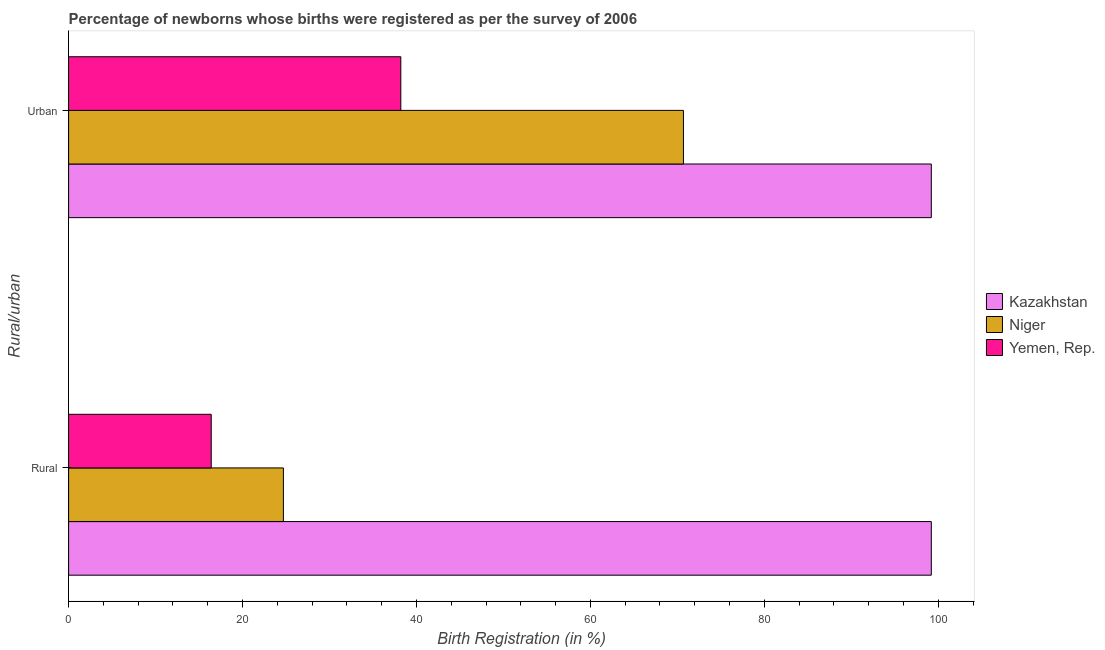Are the number of bars on each tick of the Y-axis equal?
Make the answer very short. Yes. How many bars are there on the 2nd tick from the bottom?
Your answer should be compact. 3. What is the label of the 2nd group of bars from the top?
Your answer should be very brief. Rural. What is the rural birth registration in Yemen, Rep.?
Keep it short and to the point. 16.4. Across all countries, what is the maximum urban birth registration?
Your answer should be compact. 99.2. Across all countries, what is the minimum rural birth registration?
Your answer should be very brief. 16.4. In which country was the urban birth registration maximum?
Make the answer very short. Kazakhstan. In which country was the rural birth registration minimum?
Your answer should be compact. Yemen, Rep. What is the total urban birth registration in the graph?
Offer a terse response. 208.1. What is the difference between the urban birth registration in Niger and that in Yemen, Rep.?
Ensure brevity in your answer.  32.5. What is the average urban birth registration per country?
Your response must be concise. 69.37. What is the difference between the rural birth registration and urban birth registration in Niger?
Offer a very short reply. -46. In how many countries, is the rural birth registration greater than 84 %?
Your answer should be compact. 1. What is the ratio of the urban birth registration in Yemen, Rep. to that in Kazakhstan?
Provide a short and direct response. 0.39. What does the 1st bar from the top in Urban represents?
Your answer should be compact. Yemen, Rep. What does the 1st bar from the bottom in Rural represents?
Give a very brief answer. Kazakhstan. How many bars are there?
Your answer should be very brief. 6. Are all the bars in the graph horizontal?
Offer a terse response. Yes. Are the values on the major ticks of X-axis written in scientific E-notation?
Offer a terse response. No. Does the graph contain any zero values?
Your answer should be compact. No. Does the graph contain grids?
Offer a very short reply. No. Where does the legend appear in the graph?
Your answer should be compact. Center right. What is the title of the graph?
Offer a very short reply. Percentage of newborns whose births were registered as per the survey of 2006. Does "Lithuania" appear as one of the legend labels in the graph?
Give a very brief answer. No. What is the label or title of the X-axis?
Ensure brevity in your answer.  Birth Registration (in %). What is the label or title of the Y-axis?
Provide a succinct answer. Rural/urban. What is the Birth Registration (in %) of Kazakhstan in Rural?
Provide a succinct answer. 99.2. What is the Birth Registration (in %) in Niger in Rural?
Keep it short and to the point. 24.7. What is the Birth Registration (in %) in Yemen, Rep. in Rural?
Offer a very short reply. 16.4. What is the Birth Registration (in %) in Kazakhstan in Urban?
Make the answer very short. 99.2. What is the Birth Registration (in %) in Niger in Urban?
Keep it short and to the point. 70.7. What is the Birth Registration (in %) of Yemen, Rep. in Urban?
Make the answer very short. 38.2. Across all Rural/urban, what is the maximum Birth Registration (in %) in Kazakhstan?
Your response must be concise. 99.2. Across all Rural/urban, what is the maximum Birth Registration (in %) in Niger?
Offer a very short reply. 70.7. Across all Rural/urban, what is the maximum Birth Registration (in %) of Yemen, Rep.?
Make the answer very short. 38.2. Across all Rural/urban, what is the minimum Birth Registration (in %) in Kazakhstan?
Offer a terse response. 99.2. Across all Rural/urban, what is the minimum Birth Registration (in %) in Niger?
Your answer should be very brief. 24.7. What is the total Birth Registration (in %) in Kazakhstan in the graph?
Give a very brief answer. 198.4. What is the total Birth Registration (in %) of Niger in the graph?
Give a very brief answer. 95.4. What is the total Birth Registration (in %) of Yemen, Rep. in the graph?
Provide a short and direct response. 54.6. What is the difference between the Birth Registration (in %) of Niger in Rural and that in Urban?
Your answer should be compact. -46. What is the difference between the Birth Registration (in %) of Yemen, Rep. in Rural and that in Urban?
Your response must be concise. -21.8. What is the difference between the Birth Registration (in %) of Kazakhstan in Rural and the Birth Registration (in %) of Niger in Urban?
Keep it short and to the point. 28.5. What is the difference between the Birth Registration (in %) of Kazakhstan in Rural and the Birth Registration (in %) of Yemen, Rep. in Urban?
Ensure brevity in your answer.  61. What is the average Birth Registration (in %) in Kazakhstan per Rural/urban?
Keep it short and to the point. 99.2. What is the average Birth Registration (in %) of Niger per Rural/urban?
Offer a terse response. 47.7. What is the average Birth Registration (in %) in Yemen, Rep. per Rural/urban?
Your response must be concise. 27.3. What is the difference between the Birth Registration (in %) in Kazakhstan and Birth Registration (in %) in Niger in Rural?
Ensure brevity in your answer.  74.5. What is the difference between the Birth Registration (in %) in Kazakhstan and Birth Registration (in %) in Yemen, Rep. in Rural?
Your answer should be compact. 82.8. What is the difference between the Birth Registration (in %) of Kazakhstan and Birth Registration (in %) of Niger in Urban?
Your response must be concise. 28.5. What is the difference between the Birth Registration (in %) of Kazakhstan and Birth Registration (in %) of Yemen, Rep. in Urban?
Your response must be concise. 61. What is the difference between the Birth Registration (in %) of Niger and Birth Registration (in %) of Yemen, Rep. in Urban?
Make the answer very short. 32.5. What is the ratio of the Birth Registration (in %) in Kazakhstan in Rural to that in Urban?
Your response must be concise. 1. What is the ratio of the Birth Registration (in %) of Niger in Rural to that in Urban?
Make the answer very short. 0.35. What is the ratio of the Birth Registration (in %) of Yemen, Rep. in Rural to that in Urban?
Your answer should be very brief. 0.43. What is the difference between the highest and the second highest Birth Registration (in %) of Niger?
Provide a short and direct response. 46. What is the difference between the highest and the second highest Birth Registration (in %) of Yemen, Rep.?
Provide a short and direct response. 21.8. What is the difference between the highest and the lowest Birth Registration (in %) in Kazakhstan?
Keep it short and to the point. 0. What is the difference between the highest and the lowest Birth Registration (in %) in Niger?
Give a very brief answer. 46. What is the difference between the highest and the lowest Birth Registration (in %) in Yemen, Rep.?
Provide a short and direct response. 21.8. 